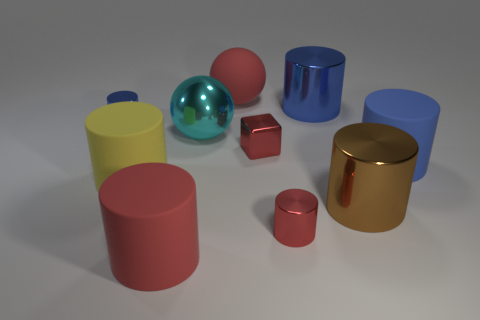Is there any other thing that is the same size as the red matte cylinder?
Make the answer very short. Yes. There is a ball that is in front of the big red sphere on the left side of the tiny block; what is it made of?
Provide a succinct answer. Metal. How many rubber things are either large things or blue cylinders?
Provide a short and direct response. 4. The other object that is the same shape as the cyan object is what color?
Offer a terse response. Red. What number of small cylinders are the same color as the tiny cube?
Your response must be concise. 1. There is a big rubber object that is right of the large brown metallic thing; is there a tiny red metal object in front of it?
Provide a short and direct response. Yes. What number of balls are in front of the tiny blue cylinder and behind the small blue cylinder?
Your answer should be very brief. 0. How many small blue objects have the same material as the big red cylinder?
Your answer should be very brief. 0. How big is the red rubber object in front of the rubber cylinder on the right side of the big rubber sphere?
Offer a terse response. Large. Is there a big red rubber object of the same shape as the cyan metallic object?
Give a very brief answer. Yes. 